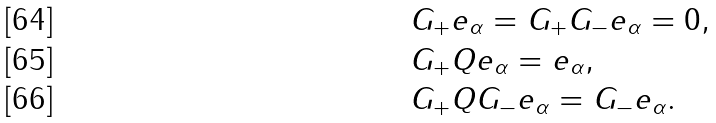<formula> <loc_0><loc_0><loc_500><loc_500>& G _ { + } e _ { \alpha } = G _ { + } G _ { - } e _ { \alpha } = 0 , \\ & G _ { + } Q e _ { \alpha } = e _ { \alpha } , \\ & G _ { + } Q G _ { - } e _ { \alpha } = G _ { - } e _ { \alpha } .</formula> 